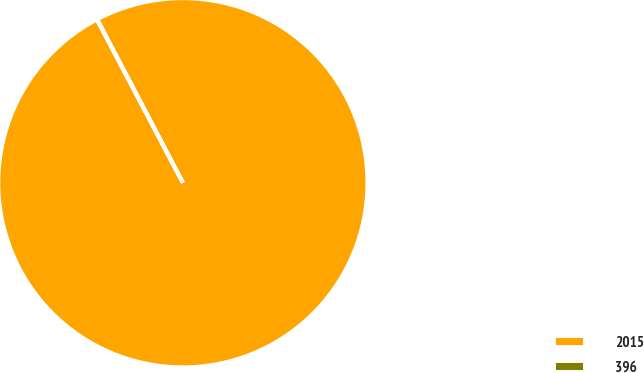Convert chart. <chart><loc_0><loc_0><loc_500><loc_500><pie_chart><fcel>2015<fcel>396<nl><fcel>99.96%<fcel>0.04%<nl></chart> 